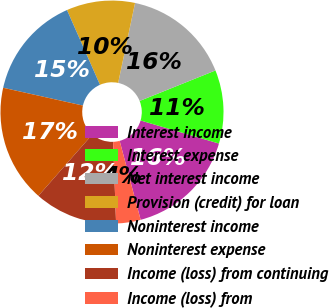Convert chart. <chart><loc_0><loc_0><loc_500><loc_500><pie_chart><fcel>Interest income<fcel>Interest expense<fcel>Net interest income<fcel>Provision (credit) for loan<fcel>Noninterest income<fcel>Noninterest expense<fcel>Income (loss) from continuing<fcel>Income (loss) from<nl><fcel>16.31%<fcel>10.64%<fcel>15.6%<fcel>9.93%<fcel>14.89%<fcel>17.02%<fcel>12.06%<fcel>3.55%<nl></chart> 